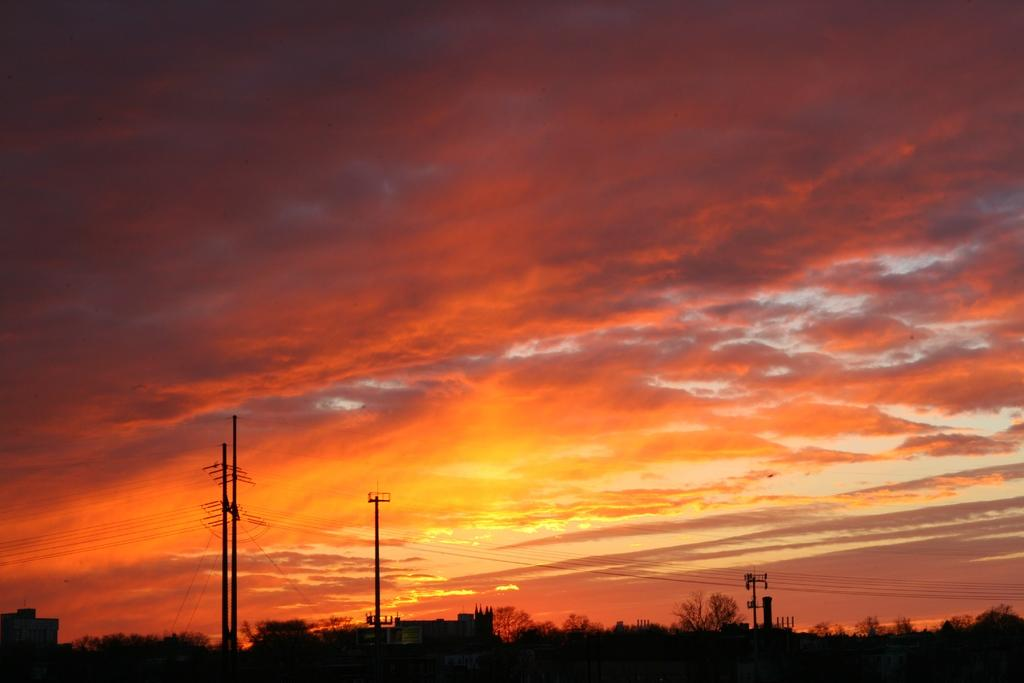What is the condition of the sky in the image? The sky in the image is cloudy. What structures can be seen in the image? There are poles visible in the image. What type of vegetation is present in the image? There are trees in the image. What else can be seen in the image besides the sky, poles, and trees? There are wires visible in the image. Can you tell me how many snails are climbing up the poles in the image? There are no snails present in the image, and therefore no such activity can be observed. What type of vacation is being depicted in the image? The image does not depict a vacation; it features a cloudy sky, poles, trees, and wires. 